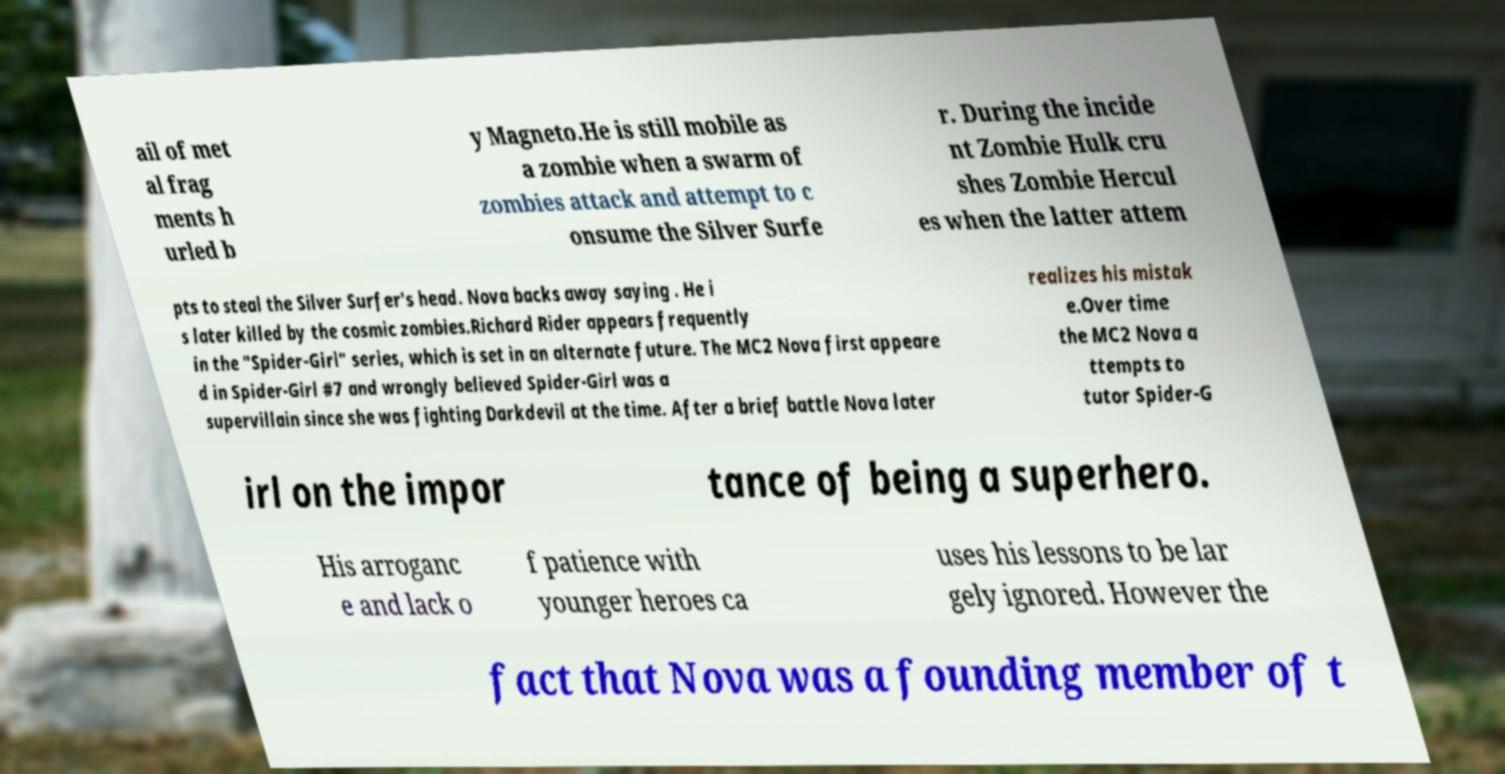Please identify and transcribe the text found in this image. ail of met al frag ments h urled b y Magneto.He is still mobile as a zombie when a swarm of zombies attack and attempt to c onsume the Silver Surfe r. During the incide nt Zombie Hulk cru shes Zombie Hercul es when the latter attem pts to steal the Silver Surfer's head. Nova backs away saying . He i s later killed by the cosmic zombies.Richard Rider appears frequently in the "Spider-Girl" series, which is set in an alternate future. The MC2 Nova first appeare d in Spider-Girl #7 and wrongly believed Spider-Girl was a supervillain since she was fighting Darkdevil at the time. After a brief battle Nova later realizes his mistak e.Over time the MC2 Nova a ttempts to tutor Spider-G irl on the impor tance of being a superhero. His arroganc e and lack o f patience with younger heroes ca uses his lessons to be lar gely ignored. However the fact that Nova was a founding member of t 